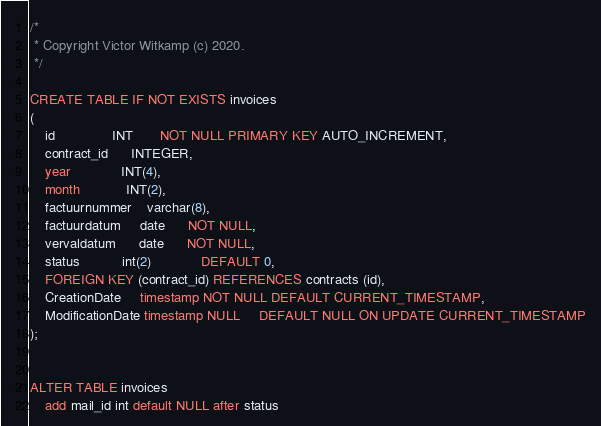Convert code to text. <code><loc_0><loc_0><loc_500><loc_500><_SQL_>/*
 * Copyright Victor Witkamp (c) 2020.
 */

CREATE TABLE IF NOT EXISTS invoices
(
    id               INT       NOT NULL PRIMARY KEY AUTO_INCREMENT,
    contract_id      INTEGER,
    year             INT(4),
    month            INT(2),
    factuurnummer    varchar(8),
    factuurdatum     date      NOT NULL,
    vervaldatum      date      NOT NULL,
    status           int(2)             DEFAULT 0,
    FOREIGN KEY (contract_id) REFERENCES contracts (id),
    CreationDate     timestamp NOT NULL DEFAULT CURRENT_TIMESTAMP,
    ModificationDate timestamp NULL     DEFAULT NULL ON UPDATE CURRENT_TIMESTAMP
);


ALTER TABLE invoices
    add mail_id int default NULL after status</code> 